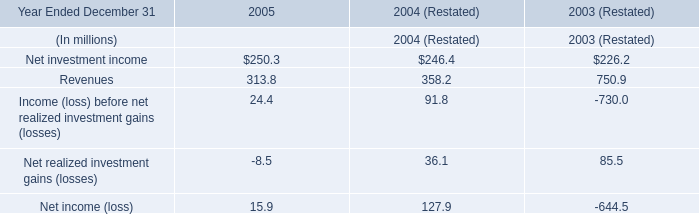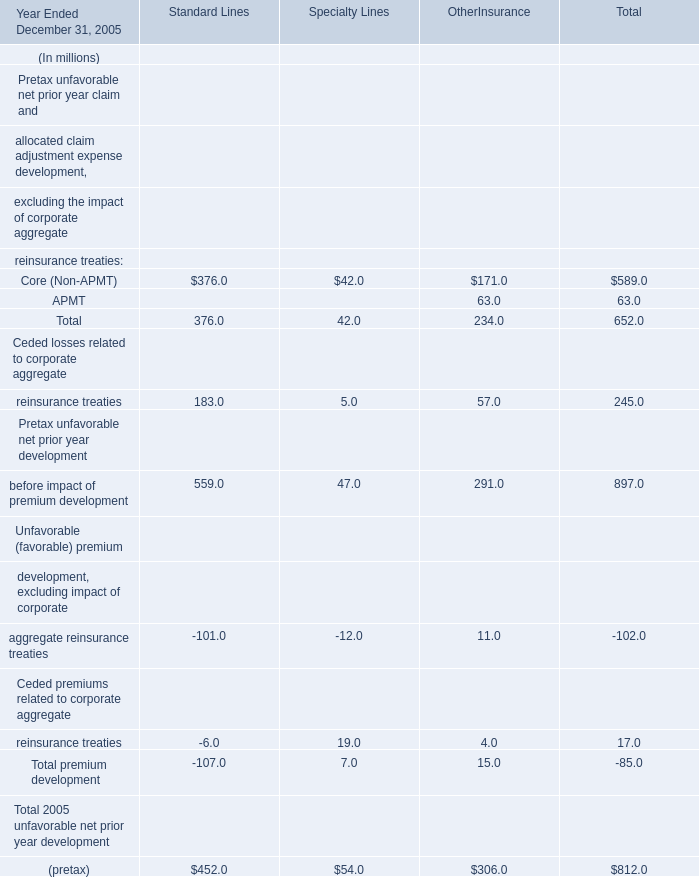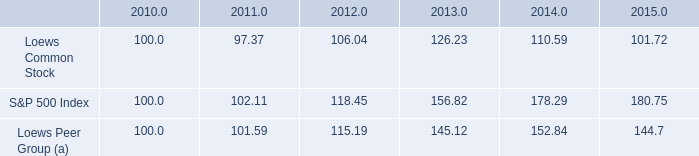What was the total amount of Specialty Lines greater than 40 in 2005 ? (in million) 
Computations: (42.0 + 54.0)
Answer: 96.0. 